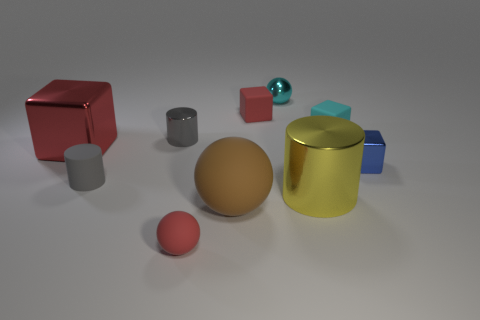Subtract all cubes. How many objects are left? 6 Add 4 tiny red blocks. How many tiny red blocks are left? 5 Add 7 tiny cyan matte spheres. How many tiny cyan matte spheres exist? 7 Subtract 1 brown balls. How many objects are left? 9 Subtract all cyan rubber things. Subtract all big metal objects. How many objects are left? 7 